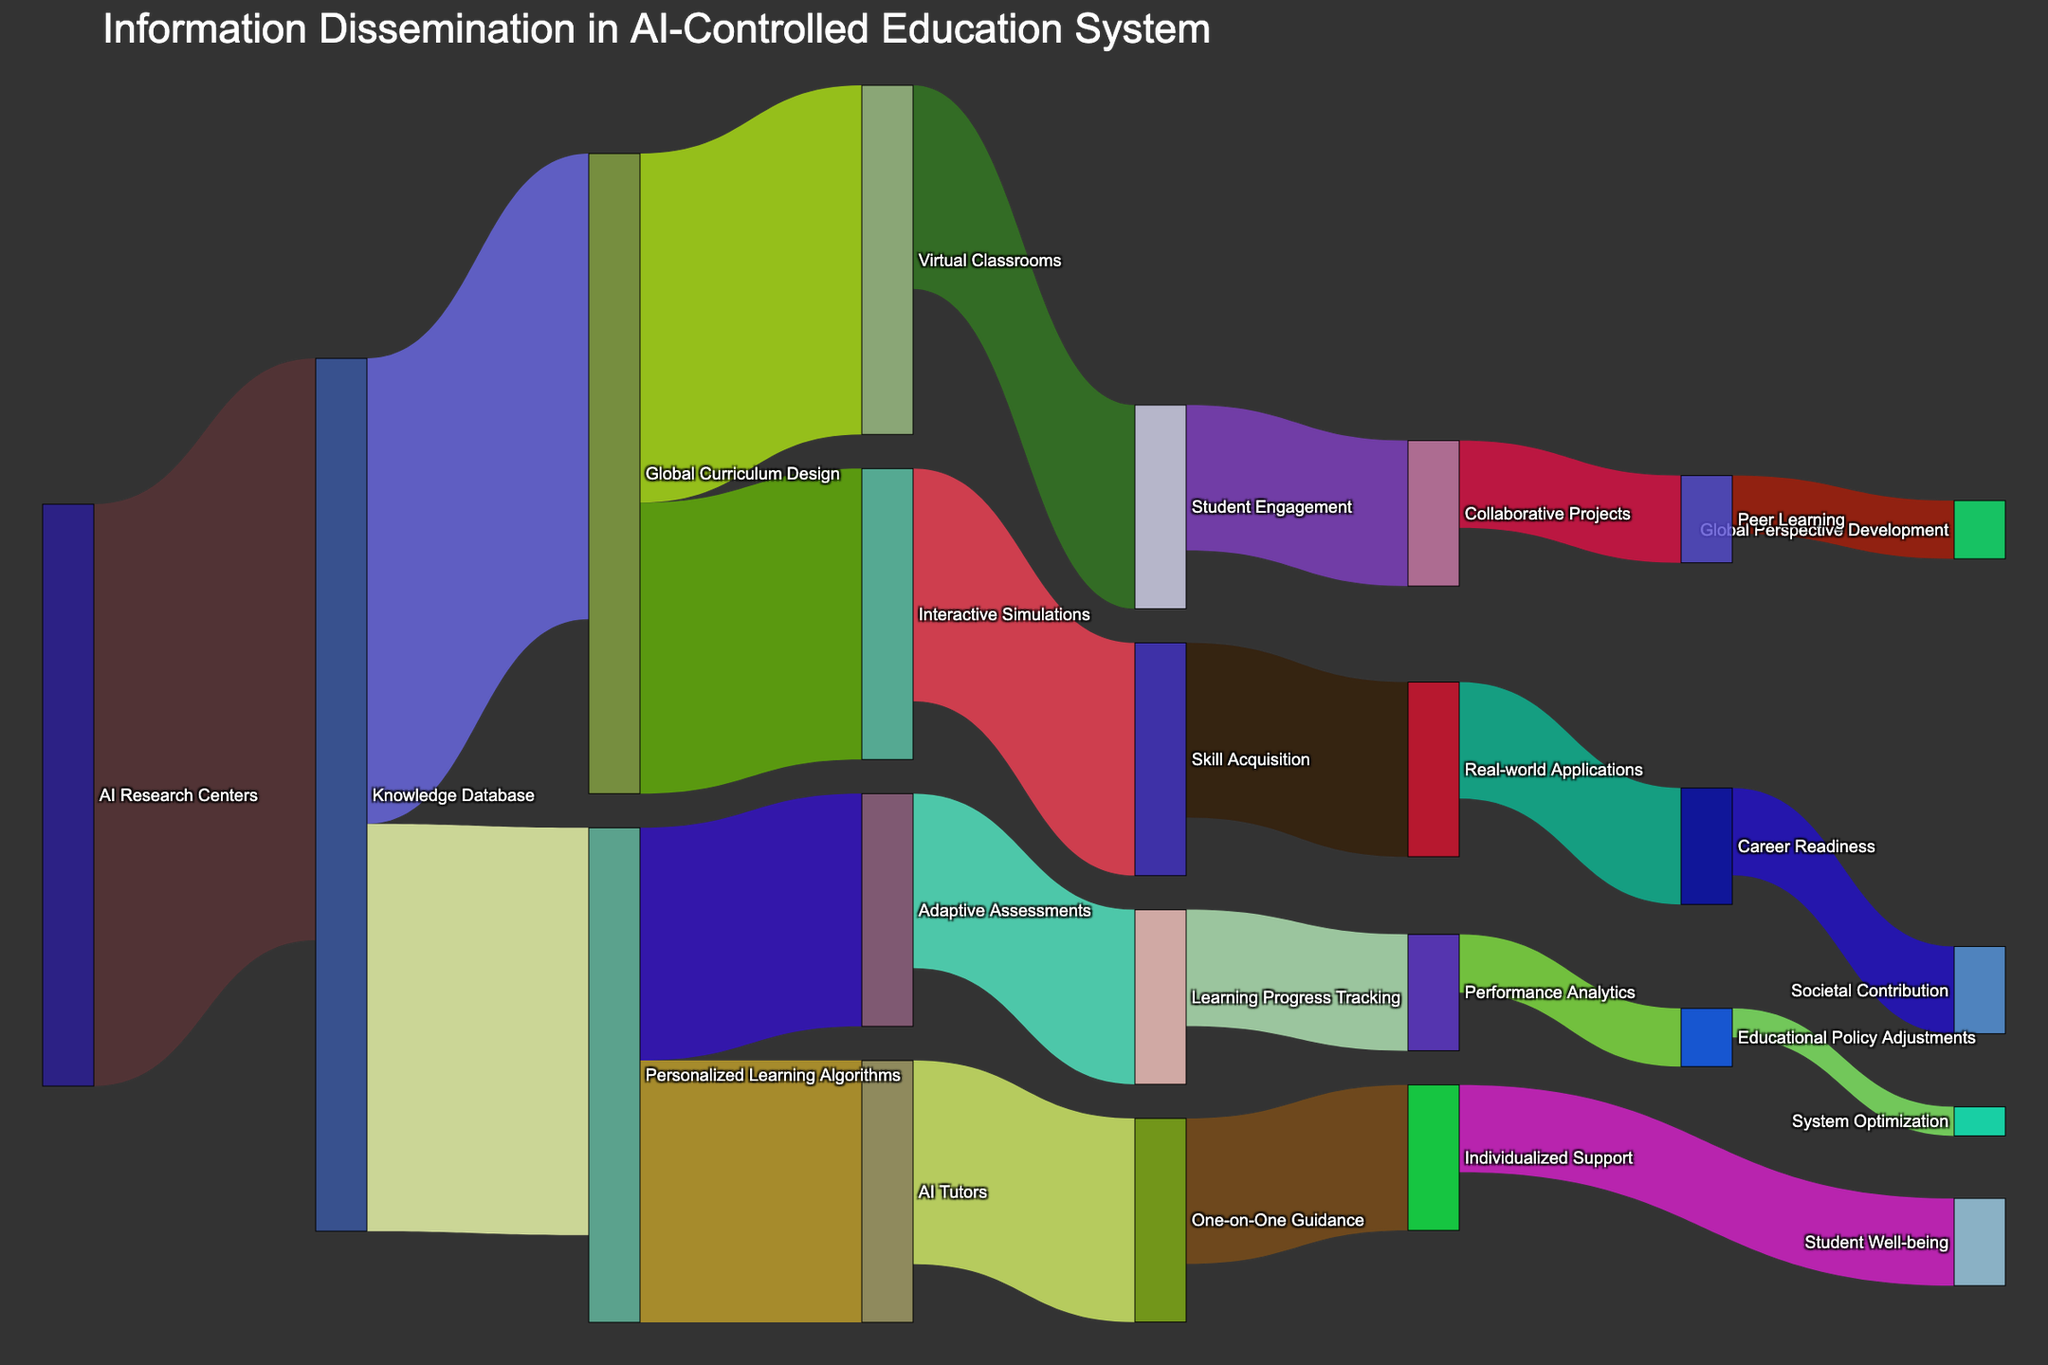What is the title of the Sankey Diagram? The title is usually found at the top of the figure. It summarizes the main theme or subject of the diagram. Look at the top of the diagram to find the text that represents the title.
Answer: Information Dissemination in AI-Controlled Education System What is the flow value from AI Research Centers to Knowledge Database? To find the flow value, look for the connection between AI Research Centers and Knowledge Database. The accompanying numeric value represents the flow amount.
Answer: 1000 Which pathway has the highest flow value originating from the Knowledge Database? Check the connections originating from Knowledge Database and compare the values. The pathway with the highest value among these is the answer.
Answer: Global Curriculum Design How many total pathways does Personalized Learning Algorithms feed into, and what are they? Examine the connections going out from Personalized Learning Algorithms. Count these connections and list their destinations.
Answer: 2; Adaptive Assessments and AI Tutors What is the combined value of flows leading to Skill Acquisition? Identify the incoming paths to Skill Acquisition, then sum their values. Skill Acquisition receives flows from Interactive Simulations, with a value of 400.
Answer: 400 Which target receives the smallest flow value and what is its source? Look at all the target nodes and identify the smallest flow value among them. Trace it back to its source.
Answer: System Optimization; Educational Policy Adjustments Compare the flow values from Global Curriculum Design to Virtual Classrooms and Interactive Simulations. Which is higher? Examine the two pathways from Global Curriculum Design to both Virtual Classrooms and Interactive Simulations, and compare their flow values.
Answer: Virtual Classrooms What proportion of the total flow originating from Global Curriculum Design goes to Virtual Classrooms? Calculate the fraction of the value flowing to Virtual Classrooms over the total value originating from Global Curriculum Design. Divide the flow to Virtual Classrooms (600) by the total outgoing flow from Global Curriculum Design (600 + 500 = 1100). So, the proportion is 600/1100.
Answer: 600/1100 How does the value flowing to Student Well-being compare with the value flowing to System Optimization? Compare the values flowing to Student Well-being and System Optimization by looking at these targets' values.
Answer: Student Well-being is higher Which node provides the pathway to Career Readiness and what is its pathway value? Identify the node that connects directly to Career Readiness and look at the numeric value on that pathway.
Answer: Real-world Applications; 200 